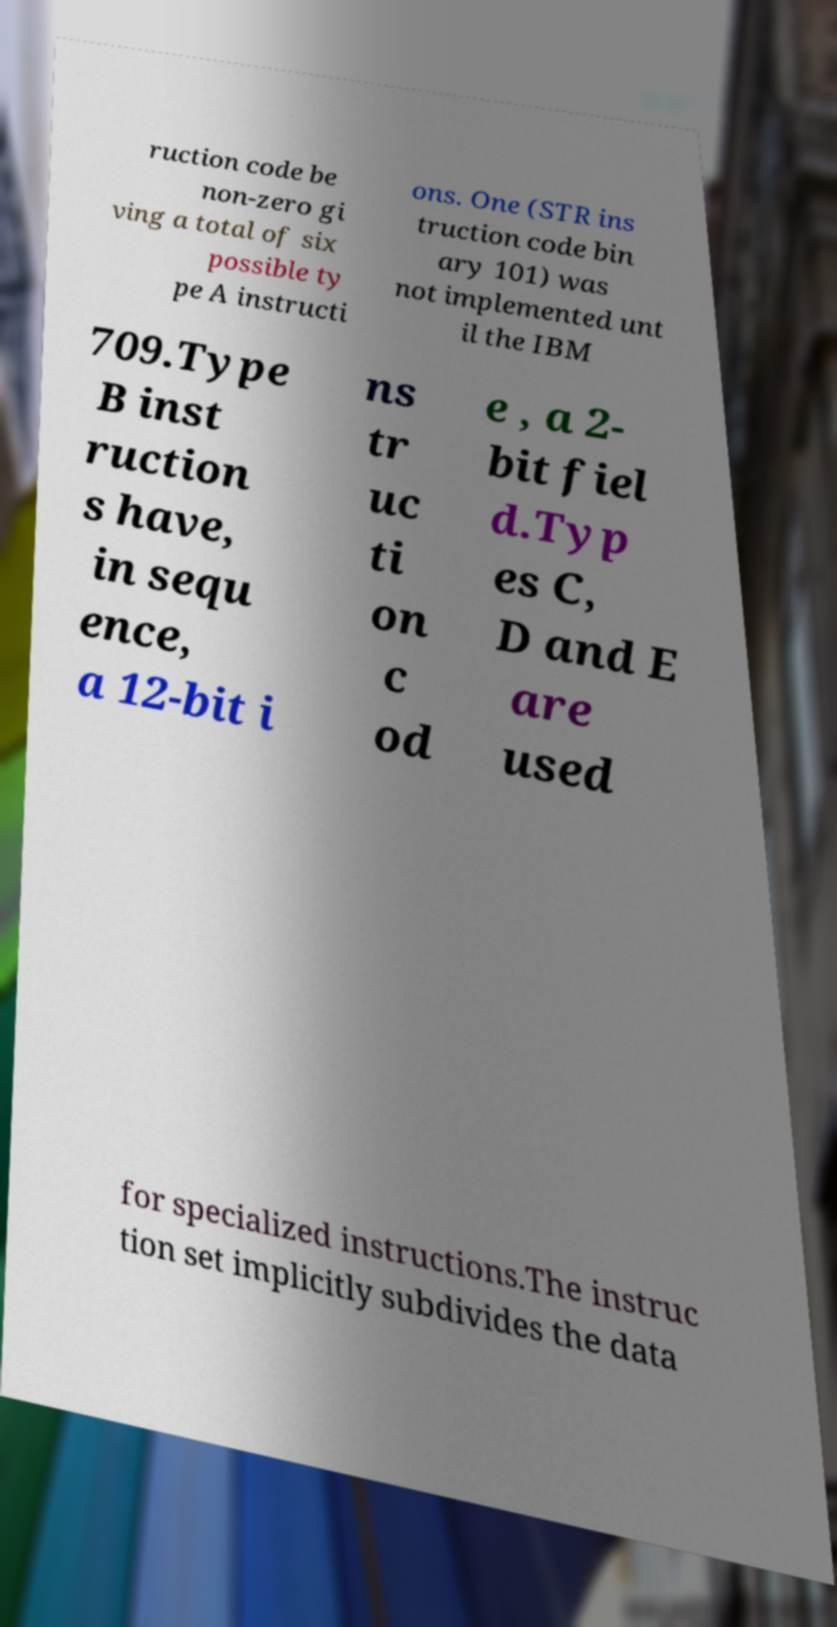What messages or text are displayed in this image? I need them in a readable, typed format. ruction code be non-zero gi ving a total of six possible ty pe A instructi ons. One (STR ins truction code bin ary 101) was not implemented unt il the IBM 709.Type B inst ruction s have, in sequ ence, a 12-bit i ns tr uc ti on c od e , a 2- bit fiel d.Typ es C, D and E are used for specialized instructions.The instruc tion set implicitly subdivides the data 